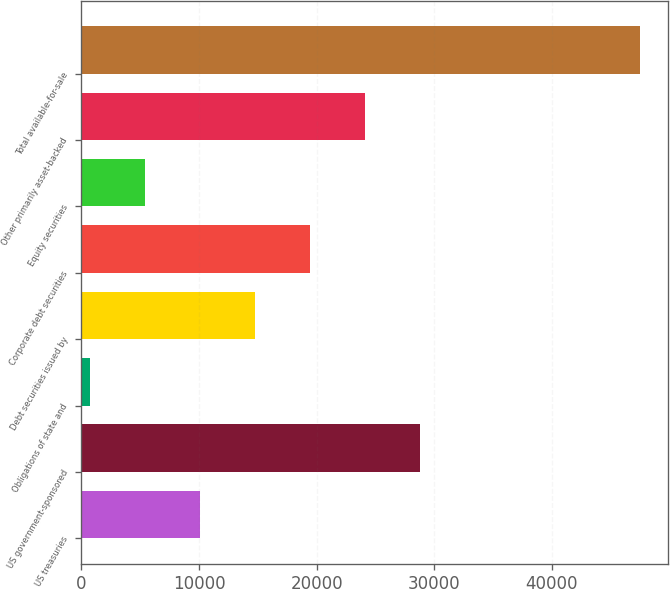<chart> <loc_0><loc_0><loc_500><loc_500><bar_chart><fcel>US treasuries<fcel>US government-sponsored<fcel>Obligations of state and<fcel>Debt securities issued by<fcel>Corporate debt securities<fcel>Equity securities<fcel>Other primarily asset-backed<fcel>Total available-for-sale<nl><fcel>10085.4<fcel>28804.2<fcel>726<fcel>14765.1<fcel>19444.8<fcel>5405.7<fcel>24124.5<fcel>47523<nl></chart> 